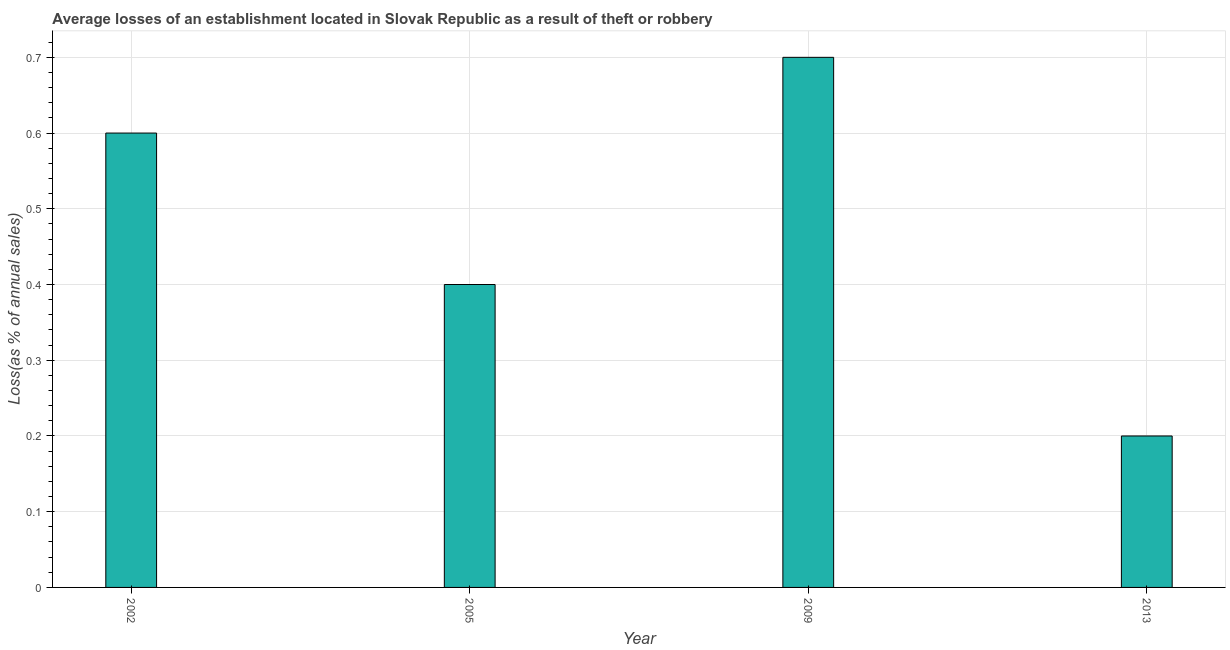Does the graph contain any zero values?
Offer a very short reply. No. What is the title of the graph?
Provide a succinct answer. Average losses of an establishment located in Slovak Republic as a result of theft or robbery. What is the label or title of the Y-axis?
Keep it short and to the point. Loss(as % of annual sales). Across all years, what is the maximum losses due to theft?
Your response must be concise. 0.7. Across all years, what is the minimum losses due to theft?
Offer a very short reply. 0.2. In which year was the losses due to theft maximum?
Keep it short and to the point. 2009. In which year was the losses due to theft minimum?
Make the answer very short. 2013. What is the average losses due to theft per year?
Ensure brevity in your answer.  0.47. In how many years, is the losses due to theft greater than 0.32 %?
Ensure brevity in your answer.  3. What is the ratio of the losses due to theft in 2002 to that in 2005?
Your answer should be compact. 1.5. Is the difference between the losses due to theft in 2002 and 2013 greater than the difference between any two years?
Your answer should be very brief. No. Is the sum of the losses due to theft in 2002 and 2013 greater than the maximum losses due to theft across all years?
Your response must be concise. Yes. What is the difference between the highest and the lowest losses due to theft?
Your response must be concise. 0.5. How many bars are there?
Offer a very short reply. 4. How many years are there in the graph?
Offer a very short reply. 4. What is the difference between two consecutive major ticks on the Y-axis?
Your answer should be compact. 0.1. Are the values on the major ticks of Y-axis written in scientific E-notation?
Offer a terse response. No. What is the Loss(as % of annual sales) in 2002?
Ensure brevity in your answer.  0.6. What is the difference between the Loss(as % of annual sales) in 2002 and 2005?
Offer a terse response. 0.2. What is the ratio of the Loss(as % of annual sales) in 2002 to that in 2009?
Keep it short and to the point. 0.86. What is the ratio of the Loss(as % of annual sales) in 2002 to that in 2013?
Offer a terse response. 3. What is the ratio of the Loss(as % of annual sales) in 2005 to that in 2009?
Make the answer very short. 0.57. What is the ratio of the Loss(as % of annual sales) in 2005 to that in 2013?
Provide a succinct answer. 2. What is the ratio of the Loss(as % of annual sales) in 2009 to that in 2013?
Keep it short and to the point. 3.5. 